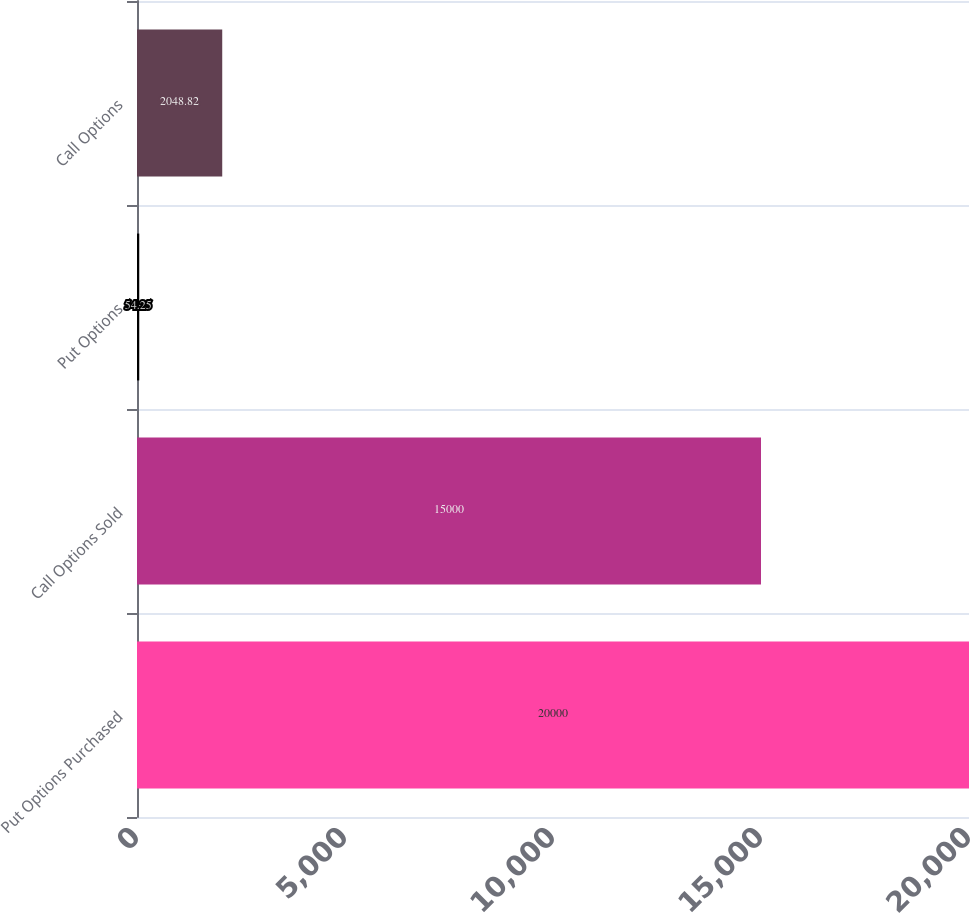<chart> <loc_0><loc_0><loc_500><loc_500><bar_chart><fcel>Put Options Purchased<fcel>Call Options Sold<fcel>Put Options<fcel>Call Options<nl><fcel>20000<fcel>15000<fcel>54.25<fcel>2048.82<nl></chart> 